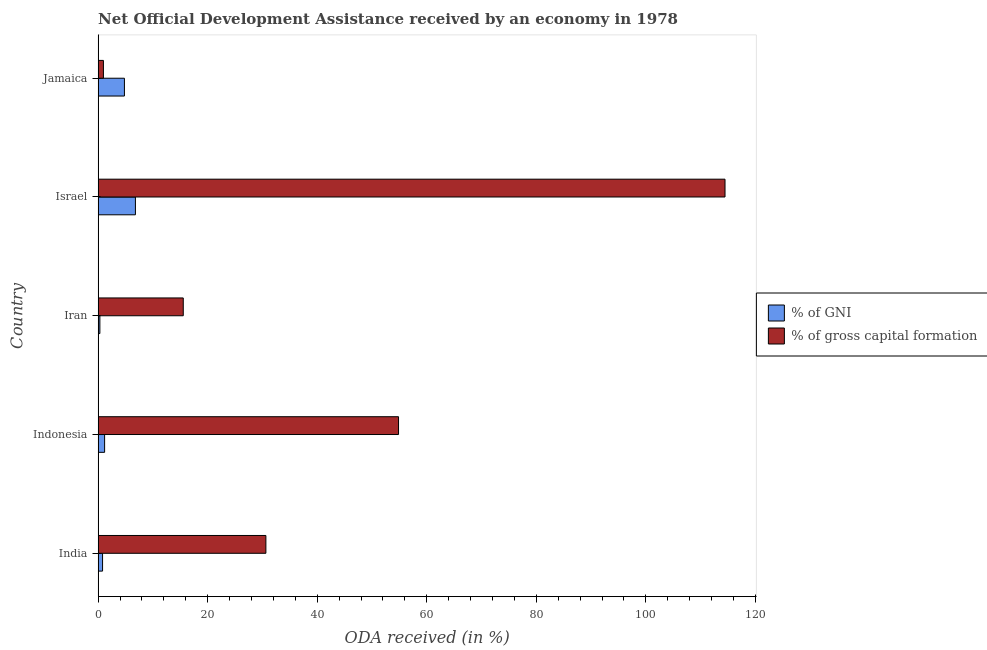How many different coloured bars are there?
Provide a succinct answer. 2. How many groups of bars are there?
Give a very brief answer. 5. Are the number of bars on each tick of the Y-axis equal?
Give a very brief answer. Yes. How many bars are there on the 2nd tick from the top?
Provide a succinct answer. 2. How many bars are there on the 5th tick from the bottom?
Keep it short and to the point. 2. What is the oda received as percentage of gross capital formation in Iran?
Offer a terse response. 15.55. Across all countries, what is the maximum oda received as percentage of gni?
Make the answer very short. 6.81. Across all countries, what is the minimum oda received as percentage of gni?
Your answer should be very brief. 0.32. In which country was the oda received as percentage of gross capital formation maximum?
Keep it short and to the point. Israel. In which country was the oda received as percentage of gni minimum?
Provide a short and direct response. Iran. What is the total oda received as percentage of gross capital formation in the graph?
Provide a succinct answer. 216.44. What is the difference between the oda received as percentage of gni in India and that in Indonesia?
Ensure brevity in your answer.  -0.37. What is the difference between the oda received as percentage of gross capital formation in Jamaica and the oda received as percentage of gni in India?
Your response must be concise. 0.16. What is the average oda received as percentage of gross capital formation per country?
Offer a very short reply. 43.29. What is the difference between the oda received as percentage of gross capital formation and oda received as percentage of gni in Jamaica?
Your answer should be very brief. -3.83. What is the ratio of the oda received as percentage of gni in India to that in Jamaica?
Offer a very short reply. 0.17. Is the oda received as percentage of gni in Indonesia less than that in Israel?
Offer a terse response. Yes. Is the difference between the oda received as percentage of gni in India and Indonesia greater than the difference between the oda received as percentage of gross capital formation in India and Indonesia?
Keep it short and to the point. Yes. What is the difference between the highest and the second highest oda received as percentage of gni?
Make the answer very short. 2.01. What is the difference between the highest and the lowest oda received as percentage of gross capital formation?
Provide a short and direct response. 113.48. Is the sum of the oda received as percentage of gross capital formation in India and Indonesia greater than the maximum oda received as percentage of gni across all countries?
Your answer should be very brief. Yes. What does the 1st bar from the top in Jamaica represents?
Provide a succinct answer. % of gross capital formation. What does the 2nd bar from the bottom in Jamaica represents?
Keep it short and to the point. % of gross capital formation. Are all the bars in the graph horizontal?
Your answer should be compact. Yes. Are the values on the major ticks of X-axis written in scientific E-notation?
Keep it short and to the point. No. Where does the legend appear in the graph?
Offer a terse response. Center right. How are the legend labels stacked?
Your answer should be compact. Vertical. What is the title of the graph?
Provide a short and direct response. Net Official Development Assistance received by an economy in 1978. Does "US$" appear as one of the legend labels in the graph?
Provide a succinct answer. No. What is the label or title of the X-axis?
Your answer should be compact. ODA received (in %). What is the ODA received (in %) of % of GNI in India?
Ensure brevity in your answer.  0.81. What is the ODA received (in %) of % of gross capital formation in India?
Give a very brief answer. 30.63. What is the ODA received (in %) of % of GNI in Indonesia?
Ensure brevity in your answer.  1.19. What is the ODA received (in %) of % of gross capital formation in Indonesia?
Offer a terse response. 54.85. What is the ODA received (in %) in % of GNI in Iran?
Your response must be concise. 0.32. What is the ODA received (in %) of % of gross capital formation in Iran?
Provide a succinct answer. 15.55. What is the ODA received (in %) in % of GNI in Israel?
Your answer should be very brief. 6.81. What is the ODA received (in %) in % of gross capital formation in Israel?
Keep it short and to the point. 114.45. What is the ODA received (in %) of % of GNI in Jamaica?
Provide a short and direct response. 4.8. What is the ODA received (in %) of % of gross capital formation in Jamaica?
Offer a terse response. 0.97. Across all countries, what is the maximum ODA received (in %) in % of GNI?
Your answer should be very brief. 6.81. Across all countries, what is the maximum ODA received (in %) of % of gross capital formation?
Keep it short and to the point. 114.45. Across all countries, what is the minimum ODA received (in %) in % of GNI?
Keep it short and to the point. 0.32. Across all countries, what is the minimum ODA received (in %) in % of gross capital formation?
Offer a very short reply. 0.97. What is the total ODA received (in %) in % of GNI in the graph?
Your answer should be compact. 13.93. What is the total ODA received (in %) of % of gross capital formation in the graph?
Your answer should be very brief. 216.44. What is the difference between the ODA received (in %) of % of GNI in India and that in Indonesia?
Your answer should be very brief. -0.37. What is the difference between the ODA received (in %) of % of gross capital formation in India and that in Indonesia?
Offer a very short reply. -24.22. What is the difference between the ODA received (in %) of % of GNI in India and that in Iran?
Offer a very short reply. 0.49. What is the difference between the ODA received (in %) of % of gross capital formation in India and that in Iran?
Your response must be concise. 15.08. What is the difference between the ODA received (in %) in % of GNI in India and that in Israel?
Provide a short and direct response. -6. What is the difference between the ODA received (in %) in % of gross capital formation in India and that in Israel?
Offer a terse response. -83.82. What is the difference between the ODA received (in %) of % of GNI in India and that in Jamaica?
Provide a succinct answer. -3.99. What is the difference between the ODA received (in %) in % of gross capital formation in India and that in Jamaica?
Offer a terse response. 29.66. What is the difference between the ODA received (in %) of % of GNI in Indonesia and that in Iran?
Ensure brevity in your answer.  0.87. What is the difference between the ODA received (in %) in % of gross capital formation in Indonesia and that in Iran?
Your response must be concise. 39.3. What is the difference between the ODA received (in %) of % of GNI in Indonesia and that in Israel?
Provide a succinct answer. -5.62. What is the difference between the ODA received (in %) of % of gross capital formation in Indonesia and that in Israel?
Provide a succinct answer. -59.6. What is the difference between the ODA received (in %) in % of GNI in Indonesia and that in Jamaica?
Offer a terse response. -3.62. What is the difference between the ODA received (in %) of % of gross capital formation in Indonesia and that in Jamaica?
Your response must be concise. 53.88. What is the difference between the ODA received (in %) of % of GNI in Iran and that in Israel?
Make the answer very short. -6.49. What is the difference between the ODA received (in %) of % of gross capital formation in Iran and that in Israel?
Your answer should be compact. -98.9. What is the difference between the ODA received (in %) in % of GNI in Iran and that in Jamaica?
Your answer should be compact. -4.48. What is the difference between the ODA received (in %) of % of gross capital formation in Iran and that in Jamaica?
Keep it short and to the point. 14.58. What is the difference between the ODA received (in %) of % of GNI in Israel and that in Jamaica?
Offer a terse response. 2.01. What is the difference between the ODA received (in %) in % of gross capital formation in Israel and that in Jamaica?
Your response must be concise. 113.48. What is the difference between the ODA received (in %) in % of GNI in India and the ODA received (in %) in % of gross capital formation in Indonesia?
Give a very brief answer. -54.03. What is the difference between the ODA received (in %) of % of GNI in India and the ODA received (in %) of % of gross capital formation in Iran?
Offer a very short reply. -14.73. What is the difference between the ODA received (in %) of % of GNI in India and the ODA received (in %) of % of gross capital formation in Israel?
Your response must be concise. -113.64. What is the difference between the ODA received (in %) of % of GNI in India and the ODA received (in %) of % of gross capital formation in Jamaica?
Provide a short and direct response. -0.16. What is the difference between the ODA received (in %) in % of GNI in Indonesia and the ODA received (in %) in % of gross capital formation in Iran?
Make the answer very short. -14.36. What is the difference between the ODA received (in %) of % of GNI in Indonesia and the ODA received (in %) of % of gross capital formation in Israel?
Provide a succinct answer. -113.26. What is the difference between the ODA received (in %) in % of GNI in Indonesia and the ODA received (in %) in % of gross capital formation in Jamaica?
Provide a succinct answer. 0.22. What is the difference between the ODA received (in %) in % of GNI in Iran and the ODA received (in %) in % of gross capital formation in Israel?
Make the answer very short. -114.13. What is the difference between the ODA received (in %) of % of GNI in Iran and the ODA received (in %) of % of gross capital formation in Jamaica?
Your answer should be compact. -0.65. What is the difference between the ODA received (in %) in % of GNI in Israel and the ODA received (in %) in % of gross capital formation in Jamaica?
Your response must be concise. 5.84. What is the average ODA received (in %) in % of GNI per country?
Give a very brief answer. 2.79. What is the average ODA received (in %) of % of gross capital formation per country?
Provide a short and direct response. 43.29. What is the difference between the ODA received (in %) in % of GNI and ODA received (in %) in % of gross capital formation in India?
Your answer should be compact. -29.82. What is the difference between the ODA received (in %) in % of GNI and ODA received (in %) in % of gross capital formation in Indonesia?
Offer a terse response. -53.66. What is the difference between the ODA received (in %) in % of GNI and ODA received (in %) in % of gross capital formation in Iran?
Provide a succinct answer. -15.23. What is the difference between the ODA received (in %) in % of GNI and ODA received (in %) in % of gross capital formation in Israel?
Keep it short and to the point. -107.64. What is the difference between the ODA received (in %) in % of GNI and ODA received (in %) in % of gross capital formation in Jamaica?
Offer a very short reply. 3.83. What is the ratio of the ODA received (in %) of % of GNI in India to that in Indonesia?
Offer a very short reply. 0.68. What is the ratio of the ODA received (in %) in % of gross capital formation in India to that in Indonesia?
Your response must be concise. 0.56. What is the ratio of the ODA received (in %) of % of GNI in India to that in Iran?
Your response must be concise. 2.54. What is the ratio of the ODA received (in %) of % of gross capital formation in India to that in Iran?
Offer a terse response. 1.97. What is the ratio of the ODA received (in %) in % of GNI in India to that in Israel?
Provide a succinct answer. 0.12. What is the ratio of the ODA received (in %) of % of gross capital formation in India to that in Israel?
Make the answer very short. 0.27. What is the ratio of the ODA received (in %) of % of GNI in India to that in Jamaica?
Give a very brief answer. 0.17. What is the ratio of the ODA received (in %) of % of gross capital formation in India to that in Jamaica?
Provide a short and direct response. 31.58. What is the ratio of the ODA received (in %) in % of GNI in Indonesia to that in Iran?
Provide a succinct answer. 3.71. What is the ratio of the ODA received (in %) in % of gross capital formation in Indonesia to that in Iran?
Offer a terse response. 3.53. What is the ratio of the ODA received (in %) in % of GNI in Indonesia to that in Israel?
Make the answer very short. 0.17. What is the ratio of the ODA received (in %) of % of gross capital formation in Indonesia to that in Israel?
Your answer should be compact. 0.48. What is the ratio of the ODA received (in %) in % of GNI in Indonesia to that in Jamaica?
Provide a short and direct response. 0.25. What is the ratio of the ODA received (in %) of % of gross capital formation in Indonesia to that in Jamaica?
Ensure brevity in your answer.  56.56. What is the ratio of the ODA received (in %) of % of GNI in Iran to that in Israel?
Your response must be concise. 0.05. What is the ratio of the ODA received (in %) in % of gross capital formation in Iran to that in Israel?
Give a very brief answer. 0.14. What is the ratio of the ODA received (in %) in % of GNI in Iran to that in Jamaica?
Give a very brief answer. 0.07. What is the ratio of the ODA received (in %) in % of gross capital formation in Iran to that in Jamaica?
Keep it short and to the point. 16.03. What is the ratio of the ODA received (in %) of % of GNI in Israel to that in Jamaica?
Your response must be concise. 1.42. What is the ratio of the ODA received (in %) of % of gross capital formation in Israel to that in Jamaica?
Offer a terse response. 118.02. What is the difference between the highest and the second highest ODA received (in %) of % of GNI?
Ensure brevity in your answer.  2.01. What is the difference between the highest and the second highest ODA received (in %) in % of gross capital formation?
Your response must be concise. 59.6. What is the difference between the highest and the lowest ODA received (in %) in % of GNI?
Keep it short and to the point. 6.49. What is the difference between the highest and the lowest ODA received (in %) in % of gross capital formation?
Your answer should be compact. 113.48. 